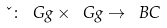Convert formula to latex. <formula><loc_0><loc_0><loc_500><loc_500>\kappa \colon \ G g \times \ G g \to \ B C</formula> 